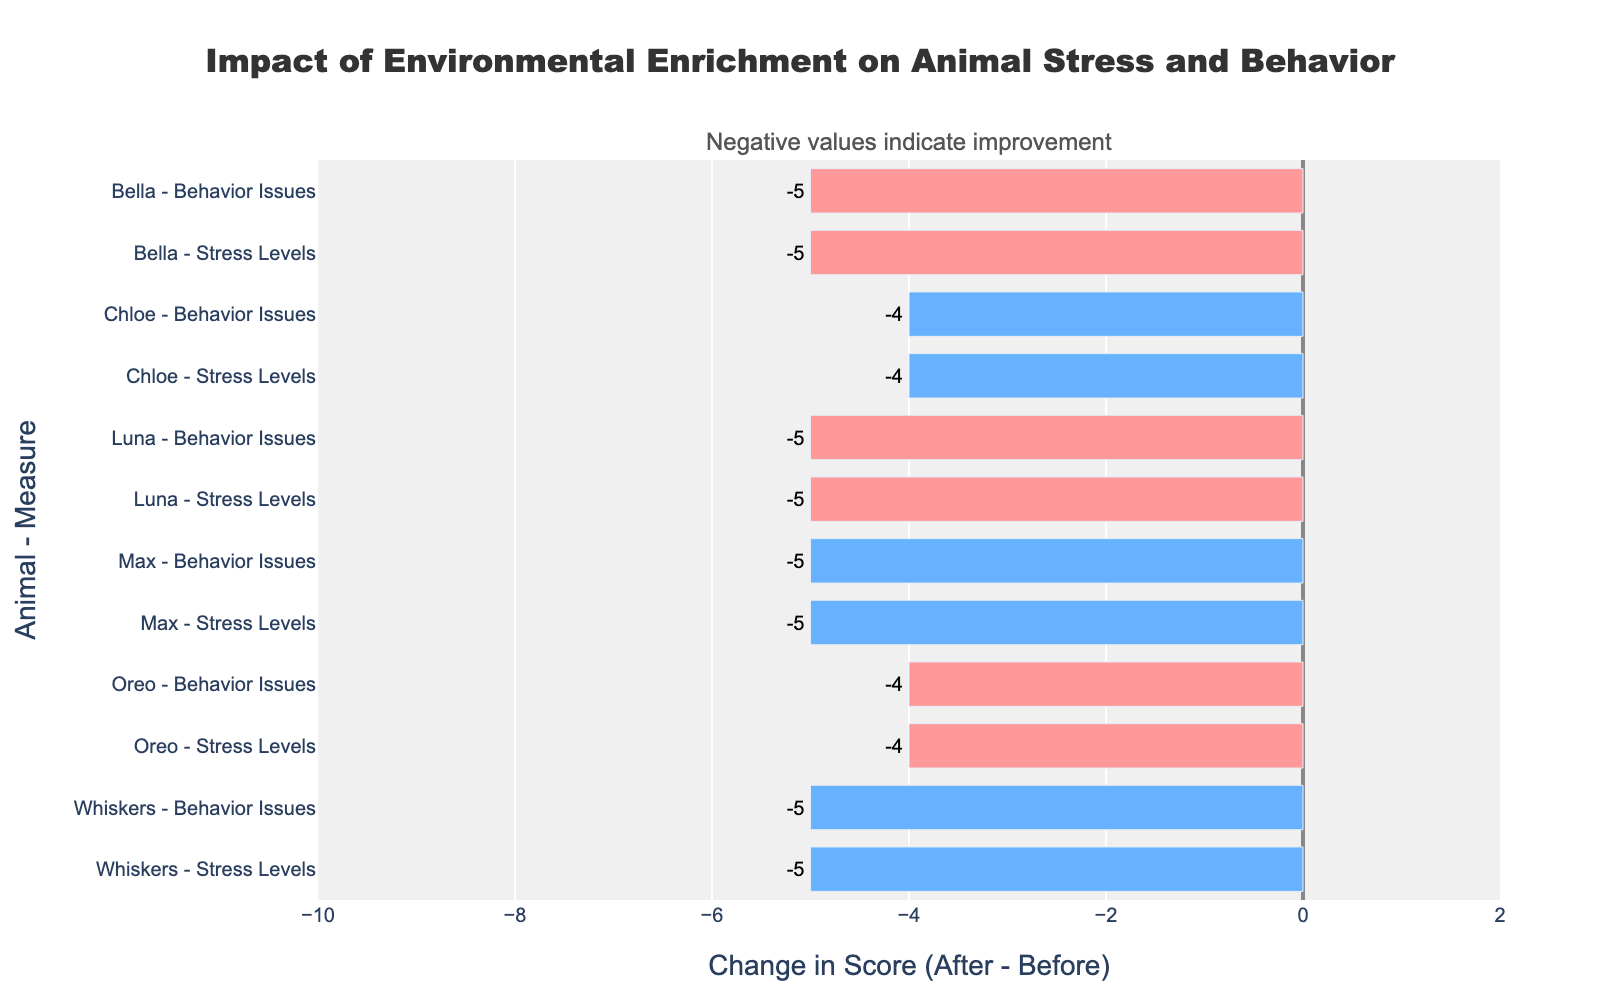What is the change in stress levels for Max the dog? To determine the change in stress levels for Max, find the difference between the before and after enrichment scores. For Max, the stress level before enrichment is 9, and after enrichment, it is 4. Therefore, the change is 4 - 9 = -5.
Answer: -5 Which animal has the largest improvement in behavior issues? To find the animal with the largest improvement, look for the most negative difference in behavior issues before and after enrichment. By examining the chart, Luna (Cat) has the largest decrease from 7 to 2, which is a change of -5.
Answer: Luna (Cat) How do the behavior issue changes compare between Bella the dog and Whiskers the cat? To compare the changes, calculate the difference for both. Bella's scores change from 8 to 3, so the difference is -5. Whiskers' scores change from 6 to 1, so the difference is also -5. Both have a difference of -5.
Answer: Equal What is the average change in stress levels across all animals? Calculate the change for each animal's stress levels, sum them, and divide by the number of animals. Changes: Luna (-5), Max (-5), Oreo (-4), Bella (-5), Whiskers (-5), Chloe (-4). Sum: -5 + -5 + -4 + -5 + -5 + -4 = -28. Average: -28 / 6 = -4.67.
Answer: -4.67 Identify the animals with a positive change in any measure. Look for animals where the after-enrichment score is higher than the before-enrichment score. All changes in the chart are negative, indicating improvements, so no animals have a positive change.
Answer: None Which animal experienced the least improvement in stress levels? Find the animal with the smallest negative (closest to zero) change in stress levels. Oreo and Chloe both experienced a change of -4, which is the smallest negative value for stress levels.
Answer: Oreo and Chloe What is the total improvement in behavior issues for all rabbits? For rabbits (Oreo and Chloe), calculate the change in behavior issues and sum them. Oreo's change is -4 (6 to 2), Chloe's change is -4 (5 to 1). Sum: -4 + -4 = -8.
Answer: -8 How many animals have shown at least a decrease of 5 points in stress levels? Count the animals with a change of -5 or lower in stress levels. They are Luna (-5), Max (-5), Bella (-5), Whiskers (-5), and Chloe (-4). So, 4 animals.
Answer: 4 